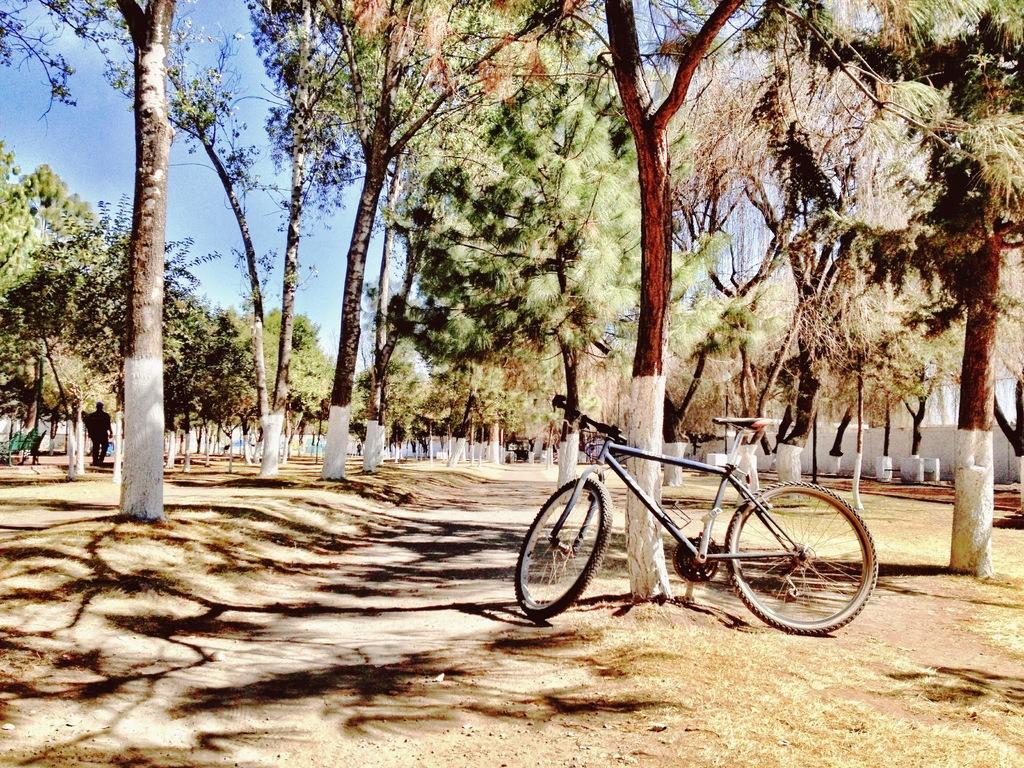What is the main subject of the image? The main subject of the image is a cycle. Where is the cycle located in relation to the tree? The cycle is in front of a tree. What other objects can be seen in the image besides the cycle and tree? There are trees and the sky visible in the image. Can you describe the sea visible in the image? There is no sea present in the image; it features a cycle in front of a tree, with additional trees and the sky visible. 